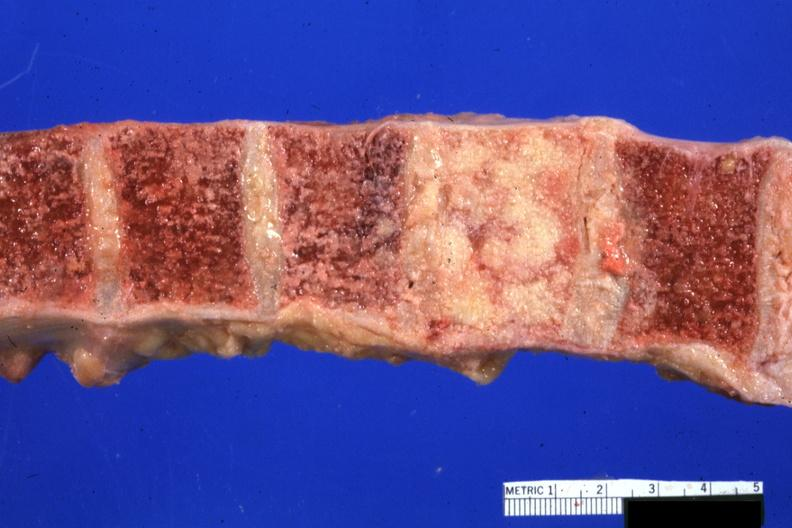what does this image show?
Answer the question using a single word or phrase. Vertebral bodies with one completely replaced by neoplasm excellent photo 68yowm cord compression 